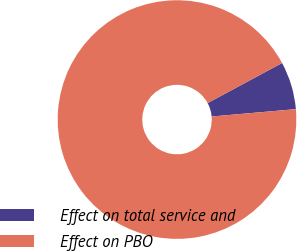Convert chart to OTSL. <chart><loc_0><loc_0><loc_500><loc_500><pie_chart><fcel>Effect on total service and<fcel>Effect on PBO<nl><fcel>6.47%<fcel>93.53%<nl></chart> 